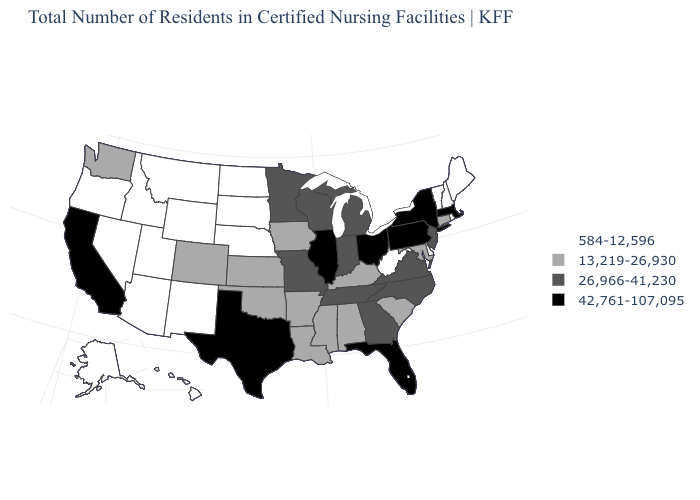What is the value of New Hampshire?
Write a very short answer. 584-12,596. How many symbols are there in the legend?
Write a very short answer. 4. Among the states that border West Virginia , which have the highest value?
Keep it brief. Ohio, Pennsylvania. Does Wyoming have the lowest value in the West?
Concise answer only. Yes. What is the value of Alaska?
Give a very brief answer. 584-12,596. What is the lowest value in the USA?
Quick response, please. 584-12,596. Name the states that have a value in the range 584-12,596?
Concise answer only. Alaska, Arizona, Delaware, Hawaii, Idaho, Maine, Montana, Nebraska, Nevada, New Hampshire, New Mexico, North Dakota, Oregon, Rhode Island, South Dakota, Utah, Vermont, West Virginia, Wyoming. Name the states that have a value in the range 13,219-26,930?
Concise answer only. Alabama, Arkansas, Colorado, Connecticut, Iowa, Kansas, Kentucky, Louisiana, Maryland, Mississippi, Oklahoma, South Carolina, Washington. Does South Dakota have the highest value in the MidWest?
Be succinct. No. What is the lowest value in states that border Colorado?
Be succinct. 584-12,596. Among the states that border Kentucky , which have the highest value?
Short answer required. Illinois, Ohio. Among the states that border Arkansas , does Tennessee have the lowest value?
Give a very brief answer. No. Does Florida have the same value as Hawaii?
Answer briefly. No. What is the value of Washington?
Short answer required. 13,219-26,930. 